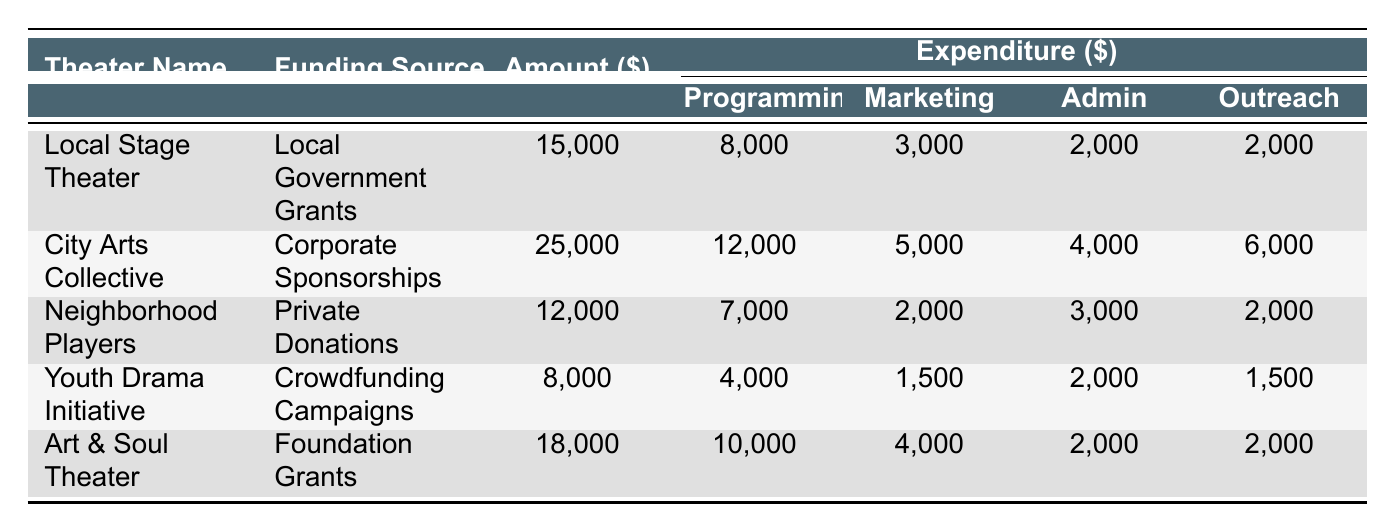What is the total funding amount for all theaters listed? To find the total funding amount, we sum the amounts from all theaters: 15000 + 25000 + 12000 + 8000 + 18000 = 78000.
Answer: 78000 Which theater received the highest amount of funding? From the table, City Arts Collective received the highest funding of 25000.
Answer: City Arts Collective What is the total expenditure on programming for all theaters? We add the programming expenditure for each theater: 8000 + 12000 + 7000 + 4000 + 10000 = 40000.
Answer: 40000 Did Youth Drama Initiative spend more on marketing than Local Stage Theater? Youth Drama Initiative spent 1500 on marketing while Local Stage Theater spent 3000, so the statement is false.
Answer: No What percentage of City Arts Collective's funding was spent on community outreach? The community outreach expenditure for City Arts Collective is 6000. The percentage is calculated as (6000 / 25000) * 100 = 24%.
Answer: 24% Which theater has the smallest total expenditure? We calculate the total expenditure for each theater: Local Stage Theater (13000), City Arts Collective (32000), Neighborhood Players (12000), Youth Drama Initiative (9500), Art & Soul Theater (16000). Youth Drama Initiative has the smallest total expenditure of 9500.
Answer: Youth Drama Initiative How much more did Local Stage Theater spend on programming compared to Youth Drama Initiative? Local Stage Theater spent 8000 on programming, while Youth Drama Initiative spent 4000. The difference is 8000 - 4000 = 4000.
Answer: 4000 Is the total amount of funding for Neighborhood Players less than that of Local Stage Theater? Neighborhood Players received 12000 and Local Stage Theater received 15000. Since 12000 is less than 15000, the statement is true.
Answer: Yes How much funding did Art & Soul Theater receive compared to its total expenditure? Art & Soul Theater received 18000 and spent a total of 16000. Thus, it received 18000 - 16000 = 2000 more than its total expenditure.
Answer: 2000 